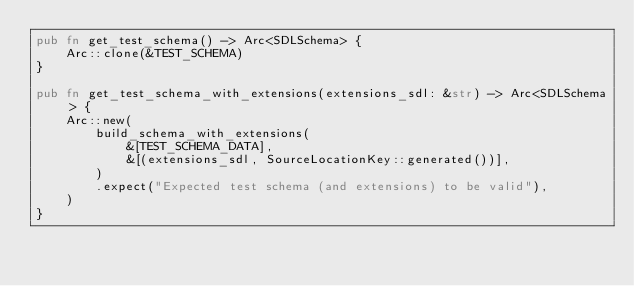<code> <loc_0><loc_0><loc_500><loc_500><_Rust_>pub fn get_test_schema() -> Arc<SDLSchema> {
    Arc::clone(&TEST_SCHEMA)
}

pub fn get_test_schema_with_extensions(extensions_sdl: &str) -> Arc<SDLSchema> {
    Arc::new(
        build_schema_with_extensions(
            &[TEST_SCHEMA_DATA],
            &[(extensions_sdl, SourceLocationKey::generated())],
        )
        .expect("Expected test schema (and extensions) to be valid"),
    )
}
</code> 